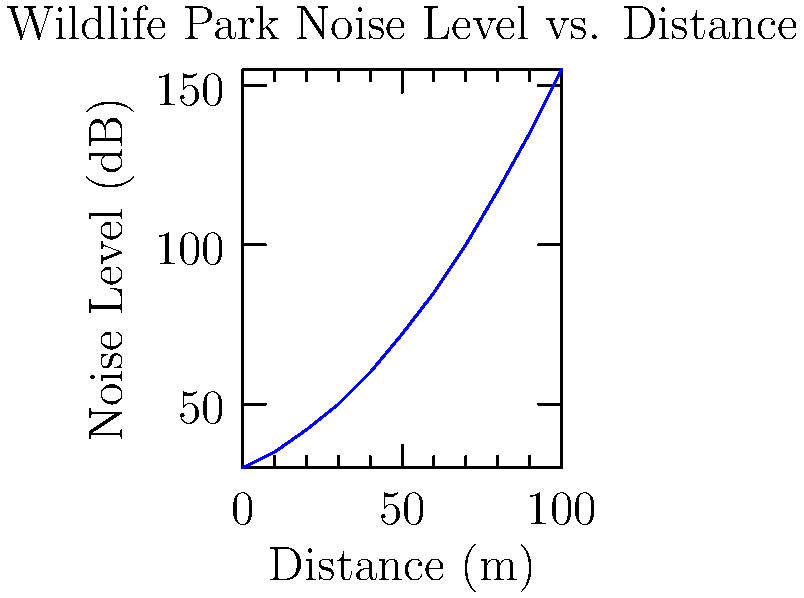Based on the graph showing the relationship between noise level and distance from a wildlife park, at what approximate distance would the noise level be reduced to 80 dB? How does this compare to the World Health Organization's recommended maximum noise level of 70 dB for residential areas? To solve this problem, we need to follow these steps:

1. Analyze the graph to find the point where the noise level is approximately 80 dB.
2. From the graph, we can see that 80 dB corresponds to a distance of about 37 meters from the wildlife park.
3. Compare this to the WHO recommendation:
   - WHO recommends a maximum of 70 dB for residential areas.
   - At 37 meters, the noise level (80 dB) still exceeds this recommendation by 10 dB.
4. To reach 70 dB, we need to go further from the park:
   - From the graph, 70 dB corresponds to approximately 50 meters.

This analysis shows that the wildlife park's noise levels exceed WHO recommendations for residential areas up to a distance of about 50 meters. As a nearby property owner, this information is crucial for assessing the impact on the local ecosystem and quality of life.

The decibel scale is logarithmic, meaning that an increase of 10 dB represents a 10-fold increase in sound intensity. Therefore, the difference between 80 dB and 70 dB is significant in terms of perceived loudness and potential impact on wildlife and residents.
Answer: 37 meters; exceeds WHO recommendation by 10 dB up to 50 meters. 